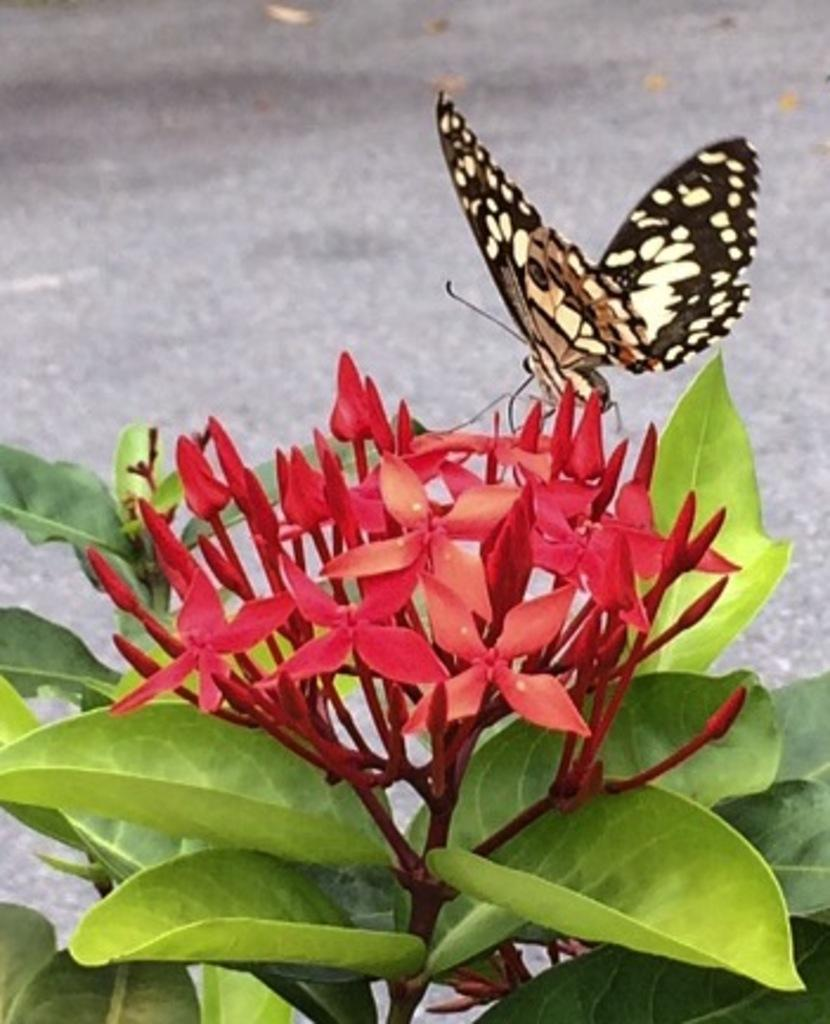What is the main subject of the image? There is a butterfly on a red flower in the image. What else can be seen in the image besides the butterfly? There is a plant at the bottom of the image and leaves visible on the left side of the image. What is located at the top of the image? There is a road at the top of the image. What is the value of the geese in the image? There are no geese present in the image, so it is not possible to determine their value. 